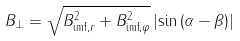Convert formula to latex. <formula><loc_0><loc_0><loc_500><loc_500>B _ { \perp } = \sqrt { B _ { \text {imf} , r } ^ { 2 } + B _ { \text {imf} , \varphi } ^ { 2 } } \left | \sin \left ( \alpha - \beta \right ) \right |</formula> 